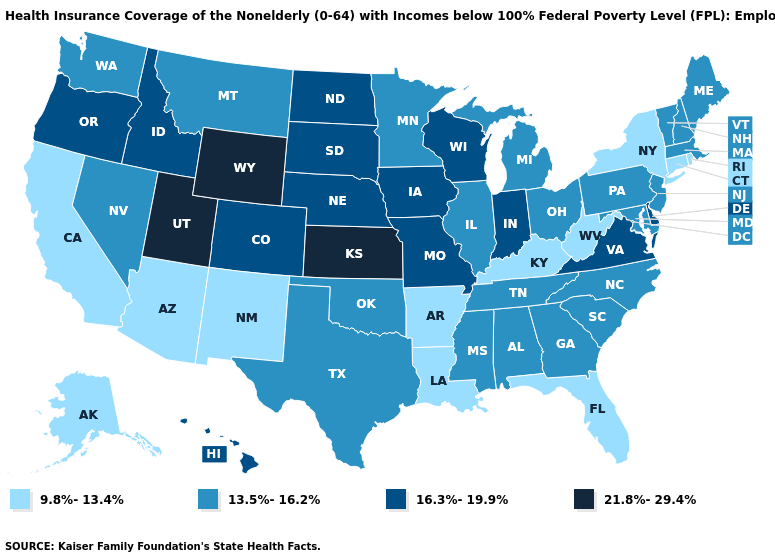What is the value of Arkansas?
Short answer required. 9.8%-13.4%. What is the highest value in states that border Virginia?
Concise answer only. 13.5%-16.2%. Name the states that have a value in the range 21.8%-29.4%?
Short answer required. Kansas, Utah, Wyoming. What is the lowest value in the MidWest?
Concise answer only. 13.5%-16.2%. Among the states that border Georgia , does South Carolina have the lowest value?
Concise answer only. No. What is the highest value in the USA?
Short answer required. 21.8%-29.4%. Which states have the lowest value in the Northeast?
Be succinct. Connecticut, New York, Rhode Island. Name the states that have a value in the range 13.5%-16.2%?
Keep it brief. Alabama, Georgia, Illinois, Maine, Maryland, Massachusetts, Michigan, Minnesota, Mississippi, Montana, Nevada, New Hampshire, New Jersey, North Carolina, Ohio, Oklahoma, Pennsylvania, South Carolina, Tennessee, Texas, Vermont, Washington. Is the legend a continuous bar?
Quick response, please. No. What is the value of Maryland?
Write a very short answer. 13.5%-16.2%. Does Kansas have the highest value in the MidWest?
Short answer required. Yes. Name the states that have a value in the range 9.8%-13.4%?
Give a very brief answer. Alaska, Arizona, Arkansas, California, Connecticut, Florida, Kentucky, Louisiana, New Mexico, New York, Rhode Island, West Virginia. What is the lowest value in the Northeast?
Write a very short answer. 9.8%-13.4%. What is the lowest value in the USA?
Quick response, please. 9.8%-13.4%. What is the lowest value in states that border Missouri?
Be succinct. 9.8%-13.4%. 